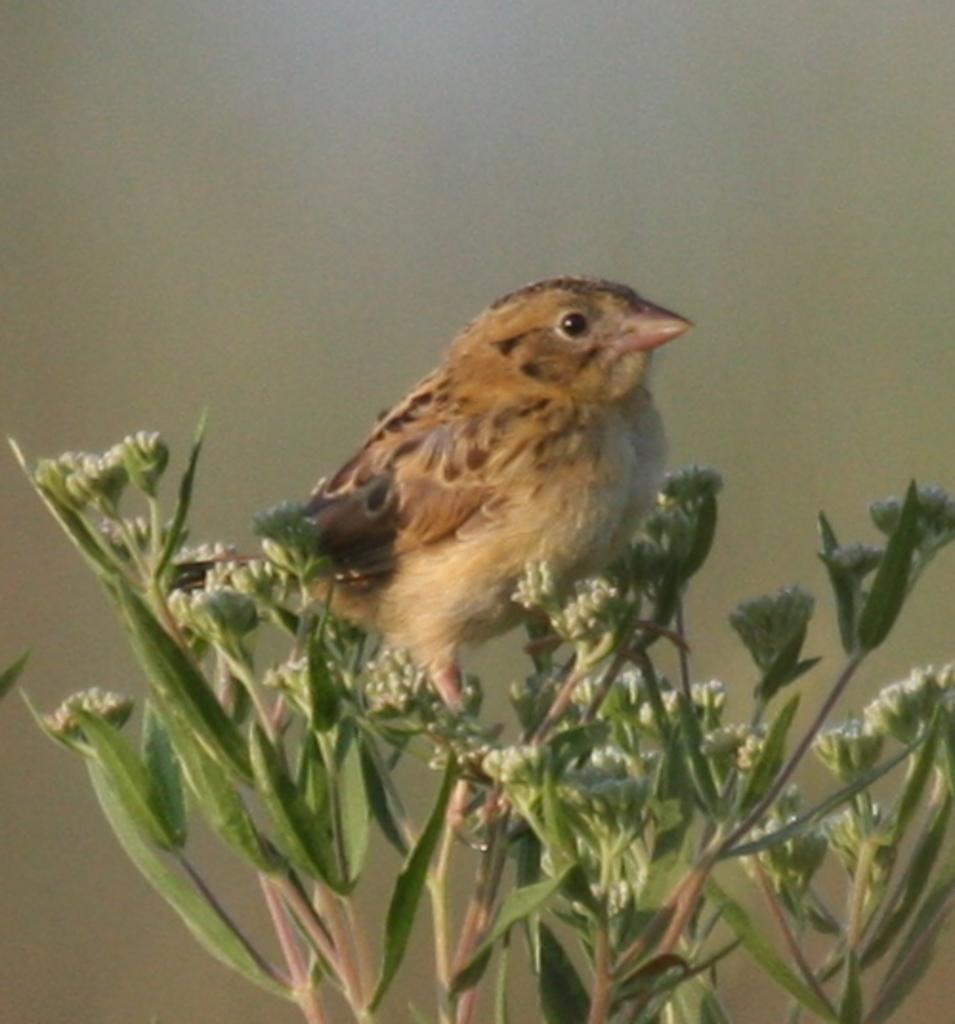Could you give a brief overview of what you see in this image? As we can see in the image there is a plant and bird. The background is blurred. 